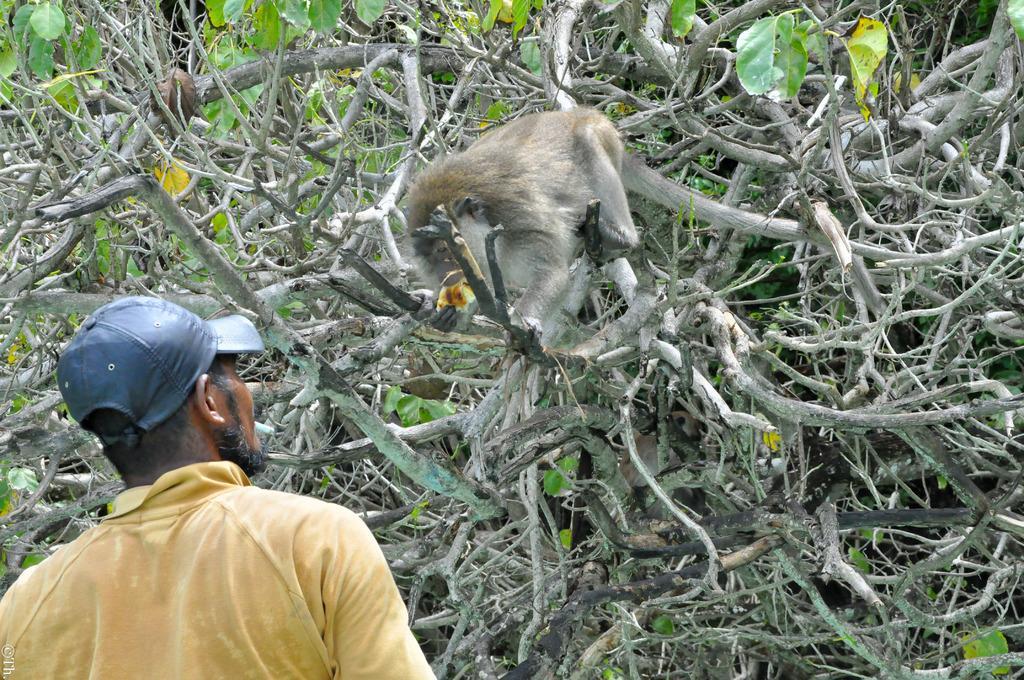Could you give a brief overview of what you see in this image? This image consists of a monkey. It is on the tree. At the bottom, we can see a man wearing a yellow shirt and a cap. In the background, there are many trees. 